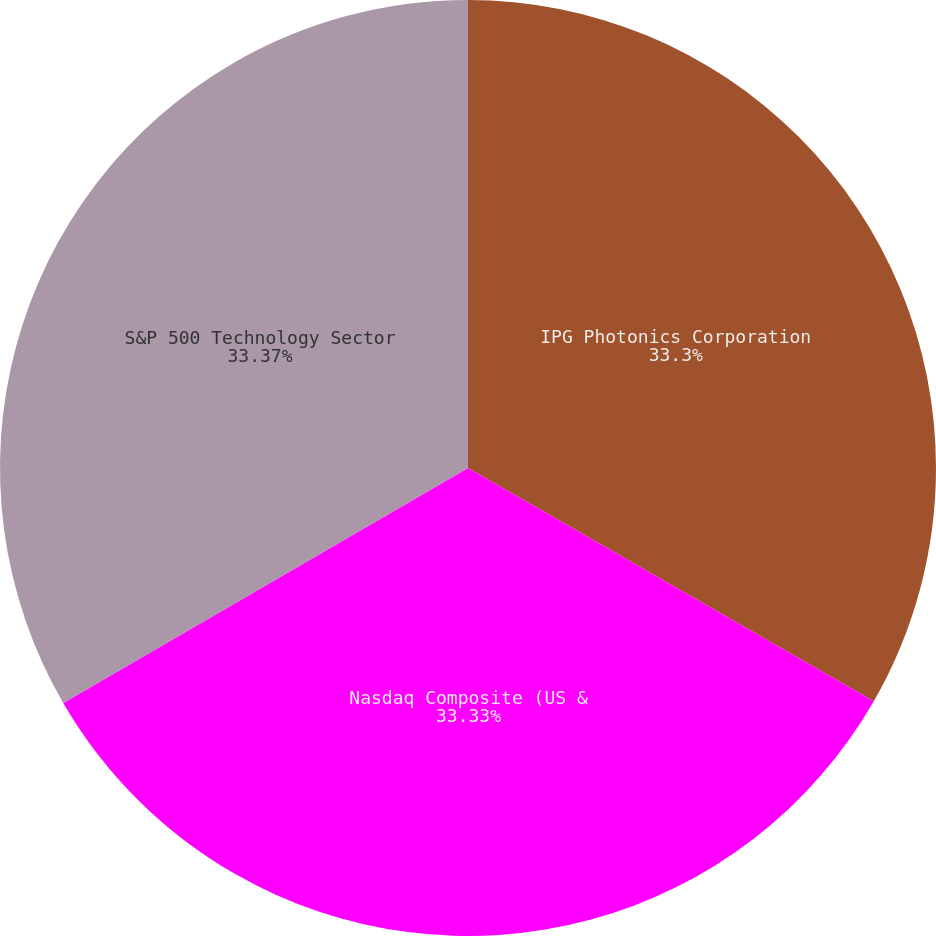Convert chart to OTSL. <chart><loc_0><loc_0><loc_500><loc_500><pie_chart><fcel>IPG Photonics Corporation<fcel>Nasdaq Composite (US &<fcel>S&P 500 Technology Sector<nl><fcel>33.3%<fcel>33.33%<fcel>33.37%<nl></chart> 